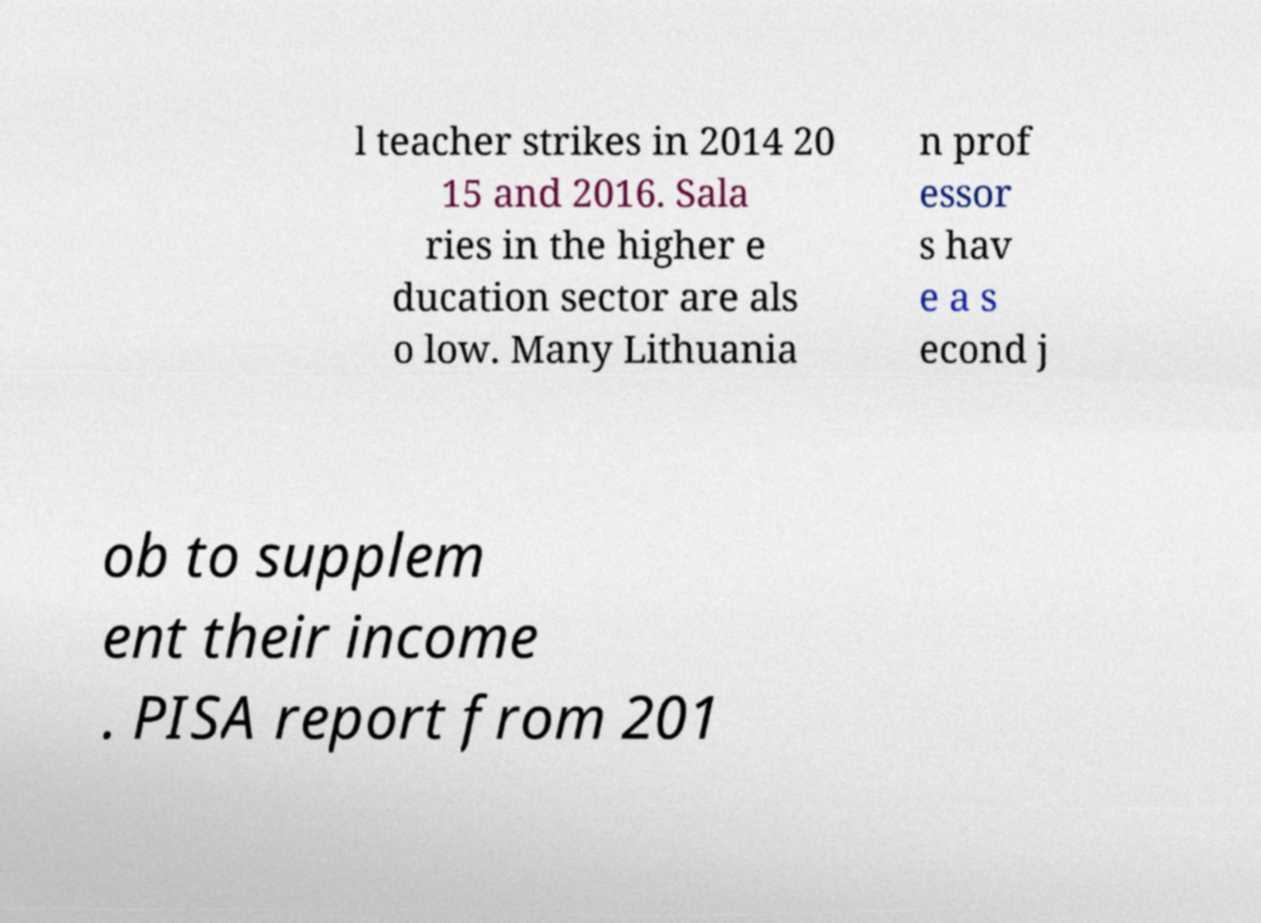What messages or text are displayed in this image? I need them in a readable, typed format. l teacher strikes in 2014 20 15 and 2016. Sala ries in the higher e ducation sector are als o low. Many Lithuania n prof essor s hav e a s econd j ob to supplem ent their income . PISA report from 201 